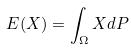Convert formula to latex. <formula><loc_0><loc_0><loc_500><loc_500>E ( X ) = \int _ { \Omega } X d P</formula> 